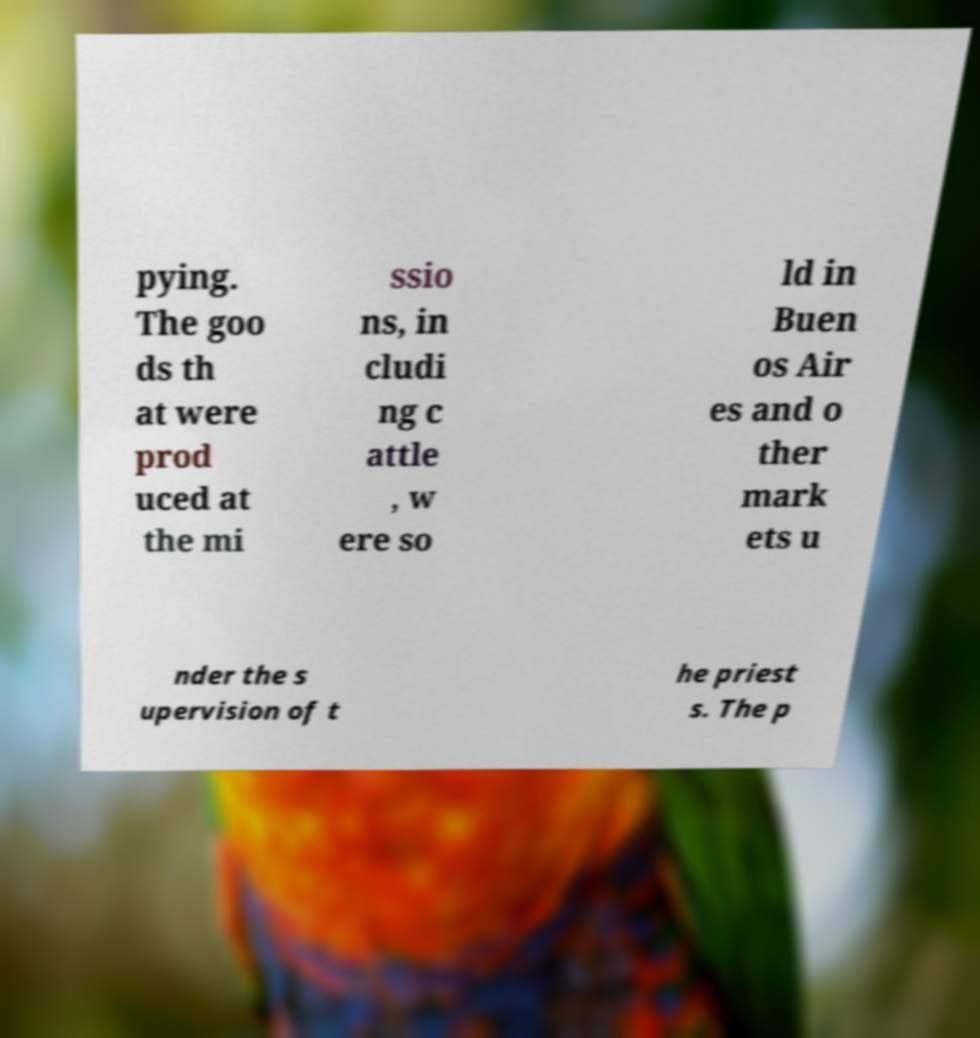There's text embedded in this image that I need extracted. Can you transcribe it verbatim? pying. The goo ds th at were prod uced at the mi ssio ns, in cludi ng c attle , w ere so ld in Buen os Air es and o ther mark ets u nder the s upervision of t he priest s. The p 